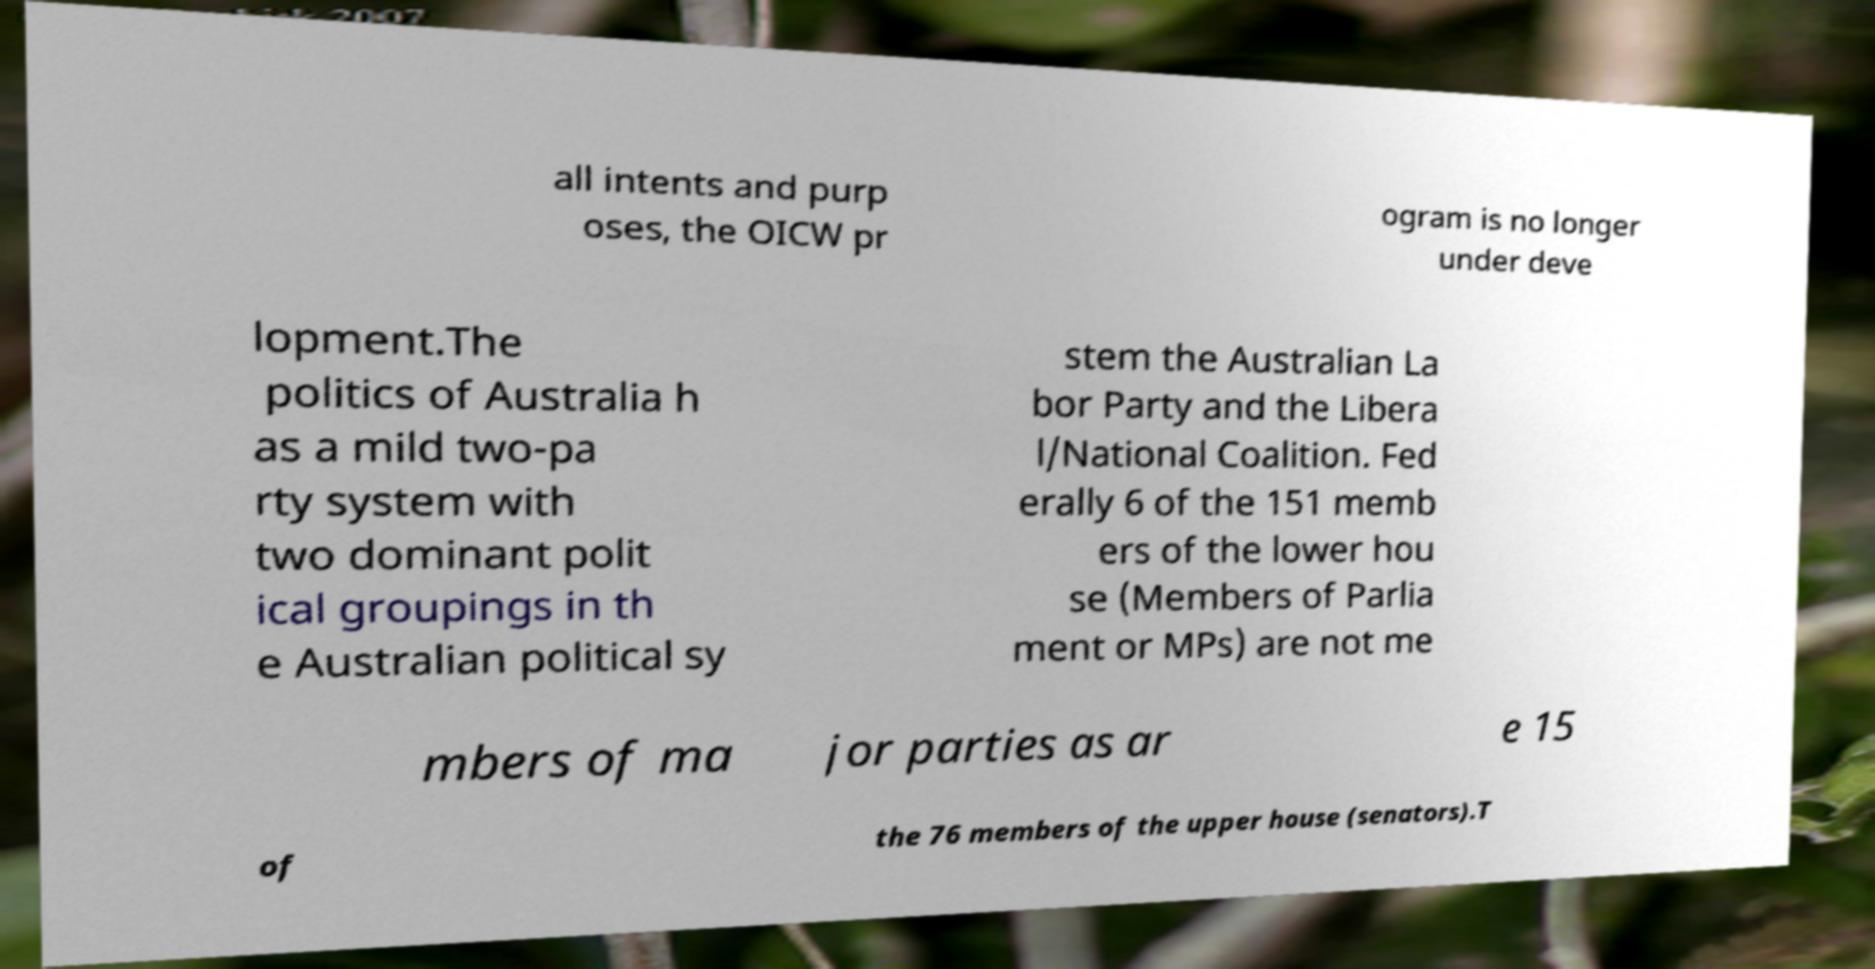For documentation purposes, I need the text within this image transcribed. Could you provide that? all intents and purp oses, the OICW pr ogram is no longer under deve lopment.The politics of Australia h as a mild two-pa rty system with two dominant polit ical groupings in th e Australian political sy stem the Australian La bor Party and the Libera l/National Coalition. Fed erally 6 of the 151 memb ers of the lower hou se (Members of Parlia ment or MPs) are not me mbers of ma jor parties as ar e 15 of the 76 members of the upper house (senators).T 